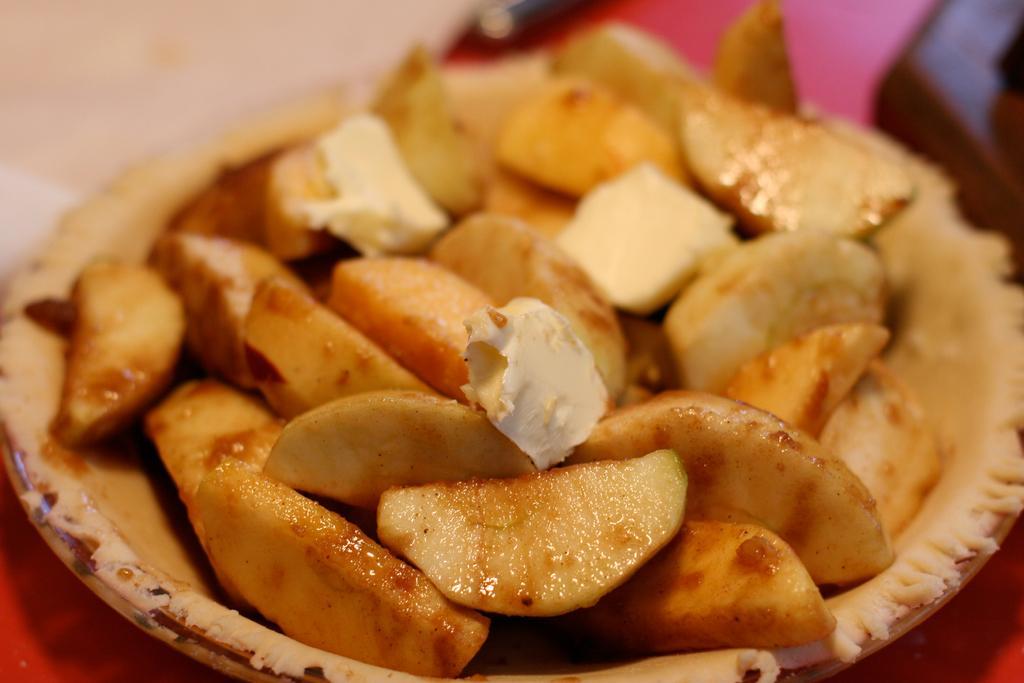In one or two sentences, can you explain what this image depicts? In this image I can see a bowl which consists of some food item. The background is blurred. 